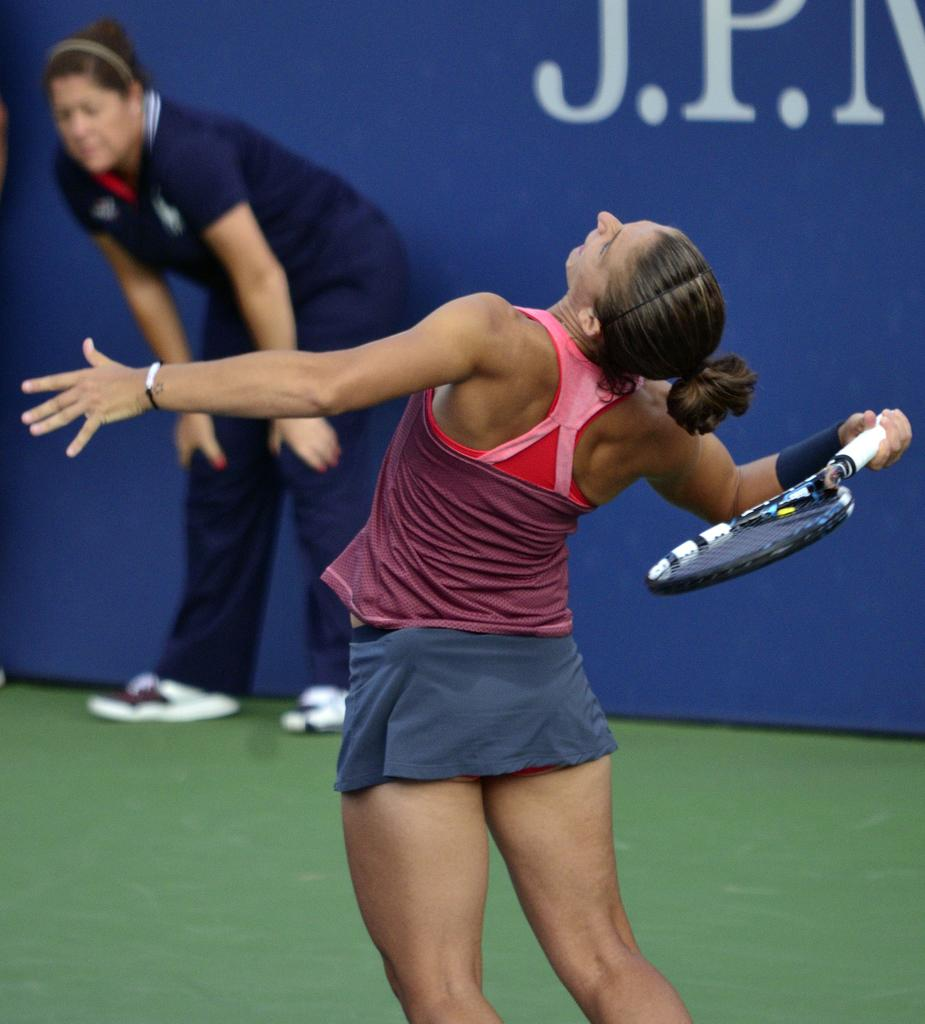How many people are in the image? There are two people in the image. What is one person holding in the image? One person is holding a racket. What type of pet can be seen in the image? There is no pet visible in the image. Can you describe the veins in the person's arm holding the racket? The image does not provide enough detail to describe the veins in the person's arm. 